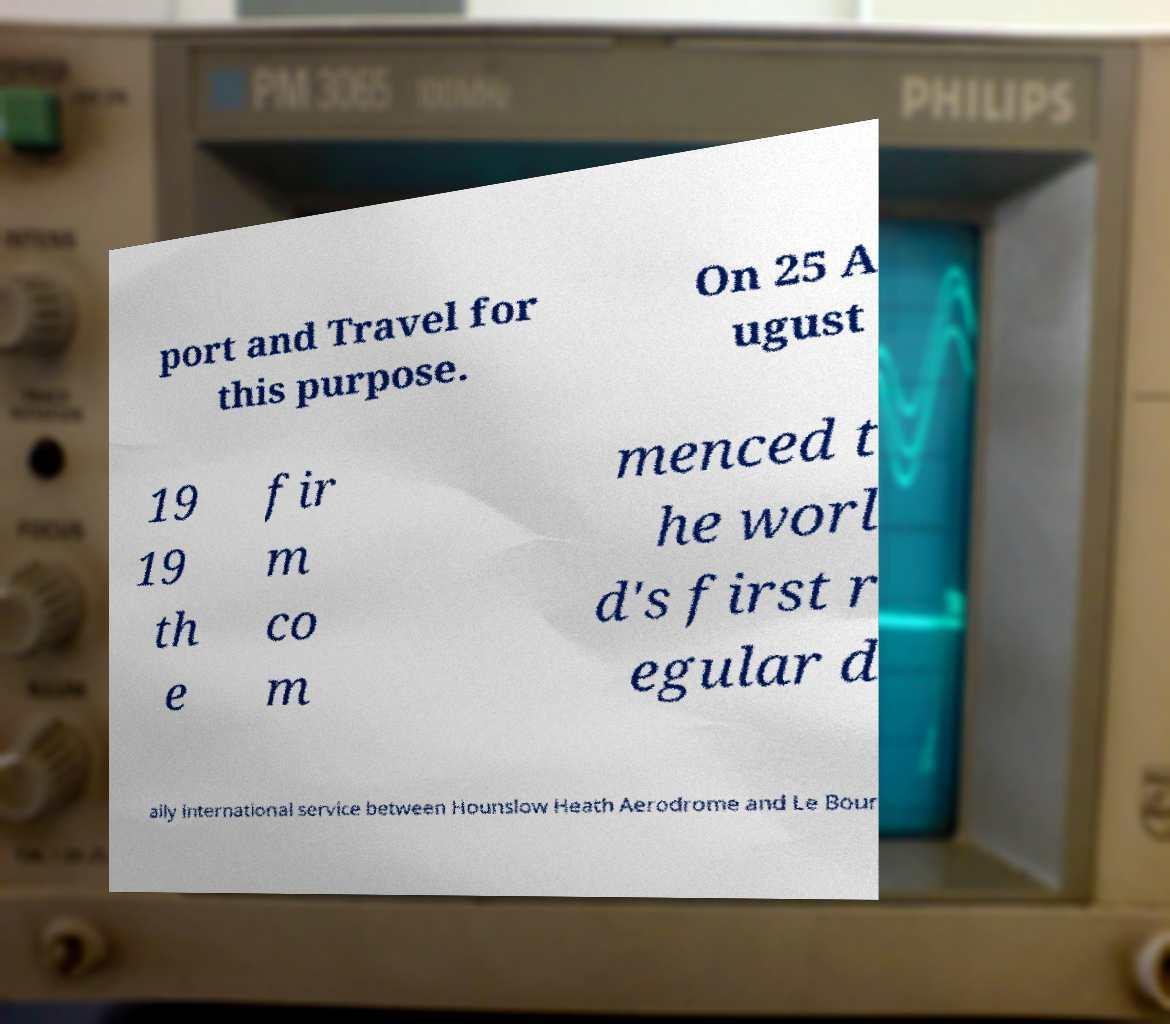Could you extract and type out the text from this image? port and Travel for this purpose. On 25 A ugust 19 19 th e fir m co m menced t he worl d's first r egular d aily international service between Hounslow Heath Aerodrome and Le Bour 